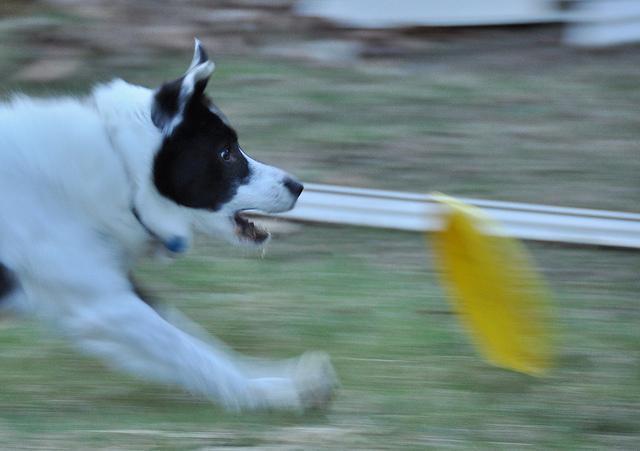How many sinks are to the right of the shower?
Give a very brief answer. 0. 